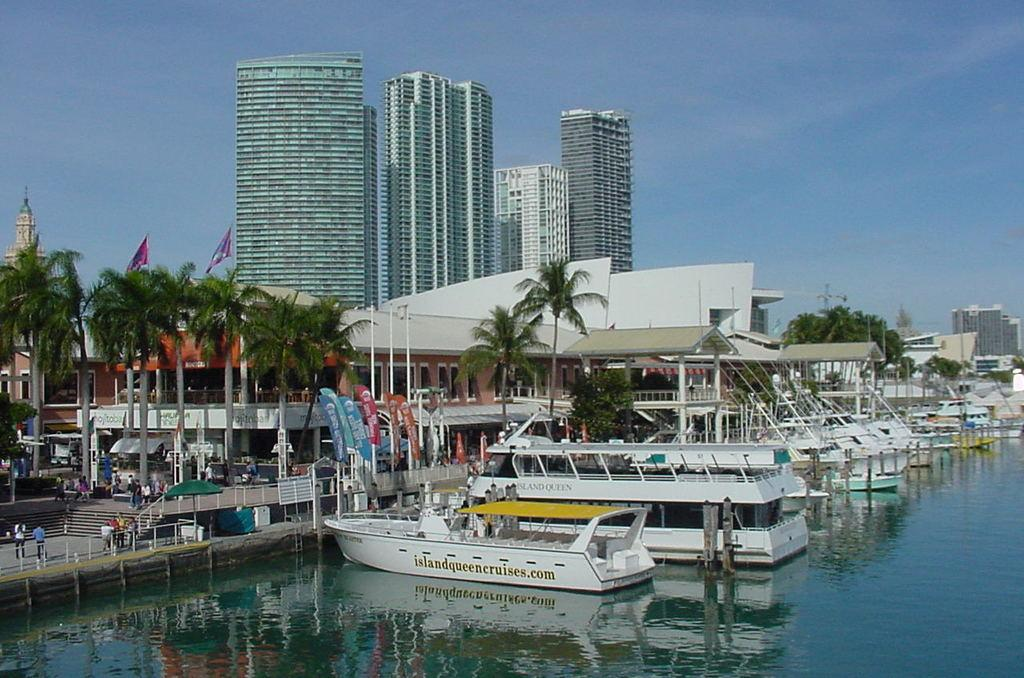What is floating on the water in the image? There are boats floating on the water in the image. What can be seen on the left side of the image? Trees are visible on the left side of the image. What is visible in the background of the image? There are buildings and the sky visible in the background of the image. What type of meal is being prepared on the boats in the image? There is no indication of any meal preparation on the boats in the image; they are simply floating on the water. What is the butter used for in the image? There is no butter present in the image. 